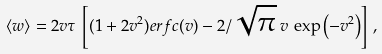Convert formula to latex. <formula><loc_0><loc_0><loc_500><loc_500>\langle w \rangle = { 2 } v \tau \, \left [ ( 1 + 2 v ^ { 2 } ) e r f c ( { v } ) - { 2 } / { \sqrt { \pi } } \, v \, \exp \left ( - { v ^ { 2 } } \right ) \right ] \, ,</formula> 